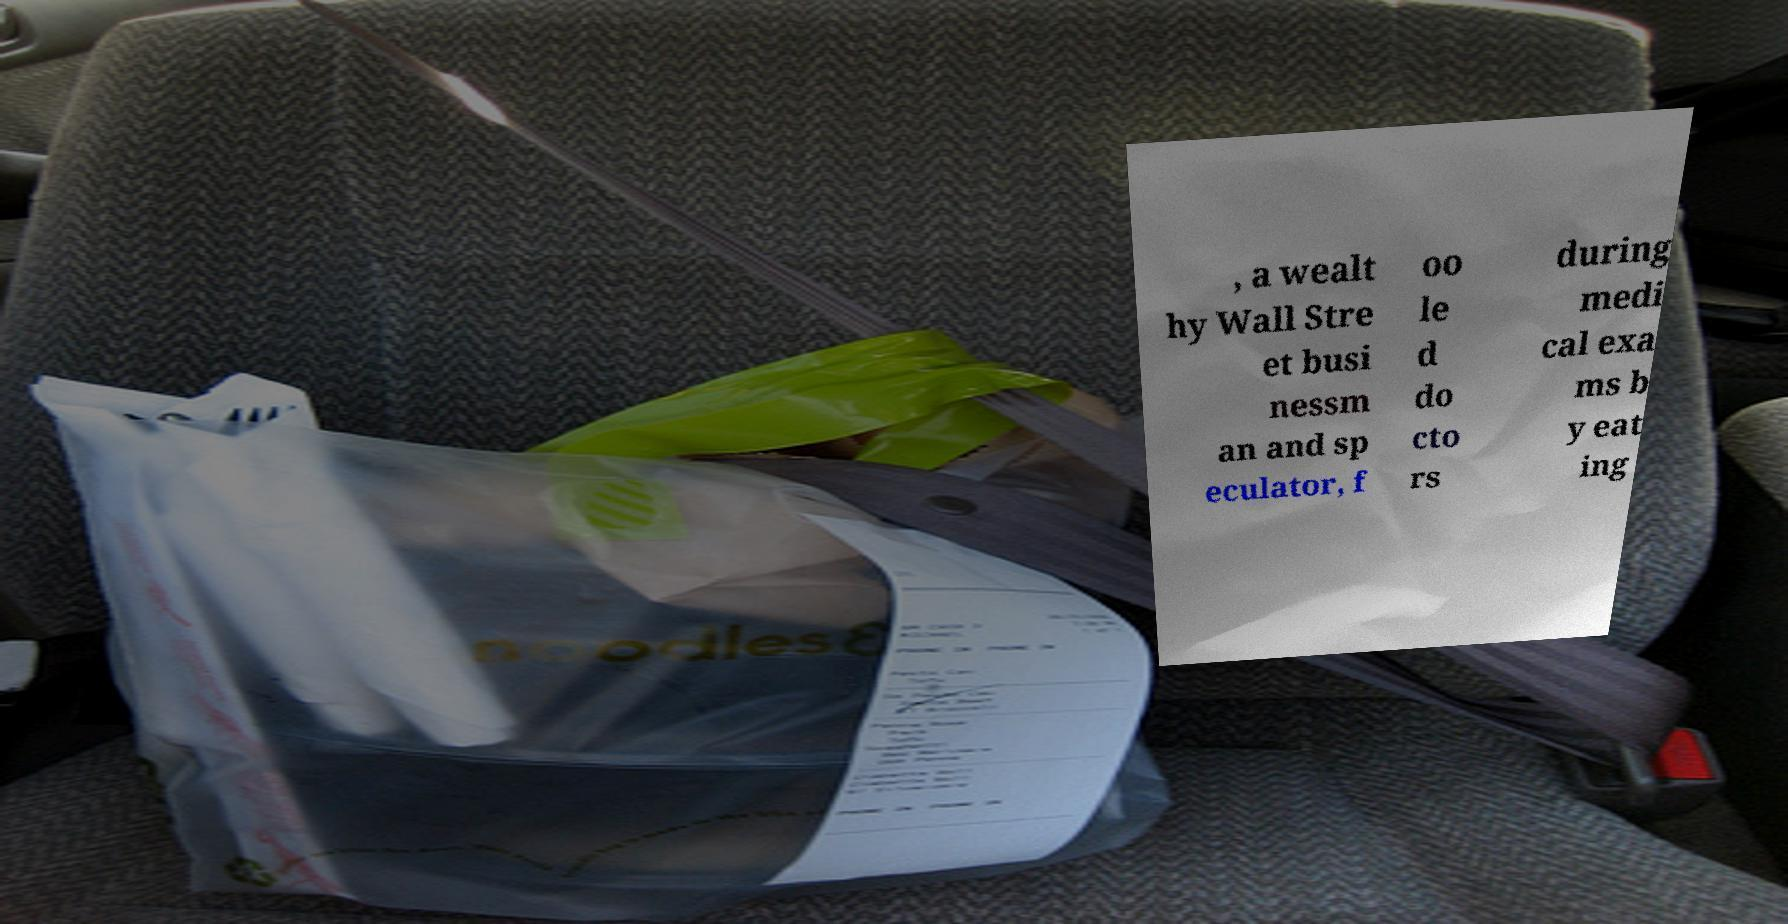Please read and relay the text visible in this image. What does it say? , a wealt hy Wall Stre et busi nessm an and sp eculator, f oo le d do cto rs during medi cal exa ms b y eat ing 